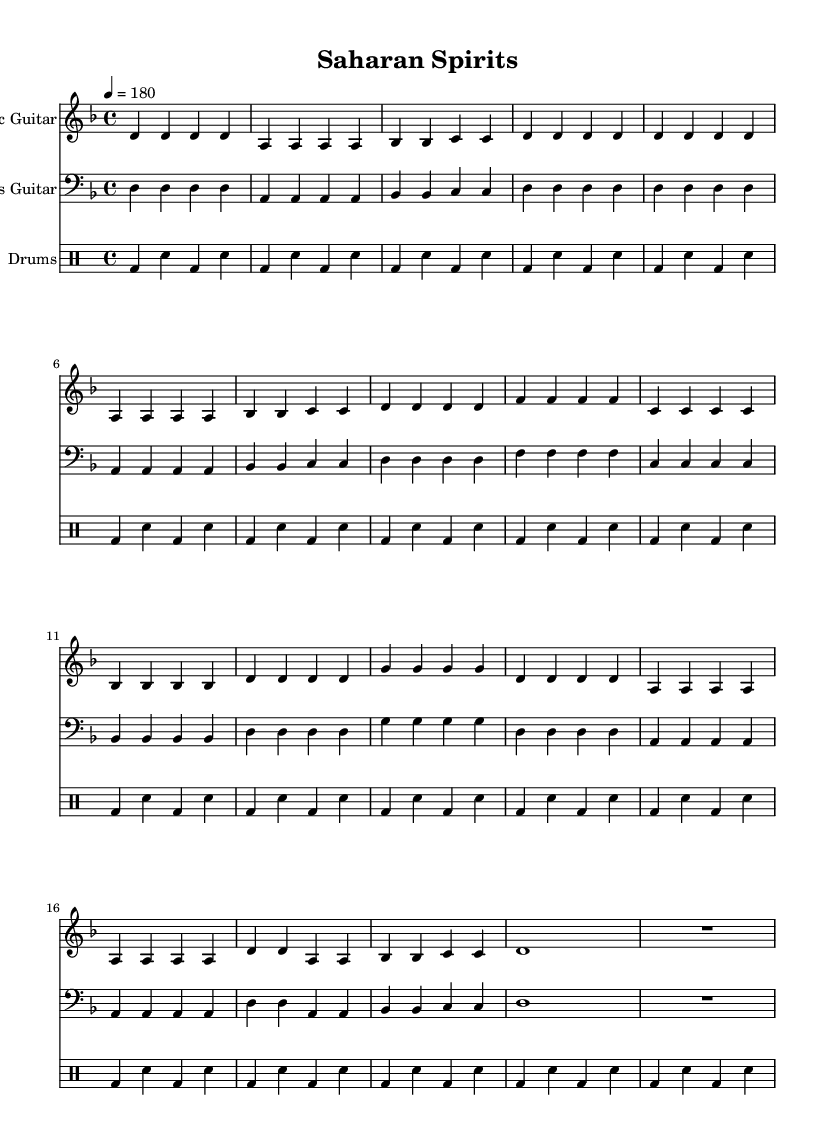What is the key signature of this music? The key signature is indicated at the beginning of the sheet music, showing two flats (B♭ and E♭), which corresponds to D minor.
Answer: D minor What is the time signature of this music? The time signature is found at the beginning of the score, specified as 4/4, meaning there are four beats in each measure and a quarter note receives one beat.
Answer: 4/4 What is the tempo marking for this music? The tempo marking is located above the staff and indicates a speed of 180 beats per minute, often notated in the form of a metronome marking.
Answer: 180 How many sections does the music have? By analyzing the structure of the music, there are five distinct sections: Intro, Verse, Chorus, Bridge, and Outro.
Answer: Five What note type is predominantly used in the chorus? The chorus section primarily consists of quarter notes, which are indicated by the visual symbols for one beat per note written in that section.
Answer: Quarter notes What rhythmic pattern is used for the drums? The drumming pattern is characterized by a bass drum on the 1st and 3rd beats, with a snare drum on the 2nd and 4th beats, creating a standard rock rhythm.
Answer: Bass and snare beat Which folklore or mythology aspects influence the lyrics of this piece? While the sheet music does not provide lyrics, the title "Saharan Spirits" suggests themes of African folklore and mythology, often represented in the music's style and inspiration.
Answer: African folklore 